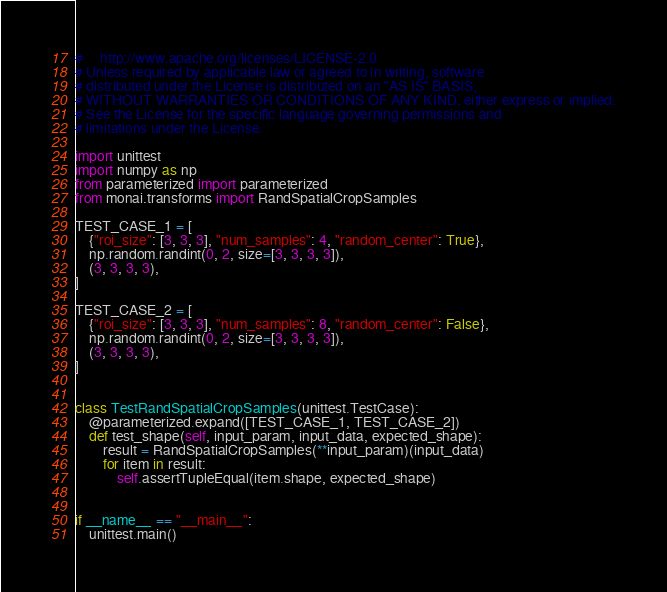<code> <loc_0><loc_0><loc_500><loc_500><_Python_>#     http://www.apache.org/licenses/LICENSE-2.0
# Unless required by applicable law or agreed to in writing, software
# distributed under the License is distributed on an "AS IS" BASIS,
# WITHOUT WARRANTIES OR CONDITIONS OF ANY KIND, either express or implied.
# See the License for the specific language governing permissions and
# limitations under the License.

import unittest
import numpy as np
from parameterized import parameterized
from monai.transforms import RandSpatialCropSamples

TEST_CASE_1 = [
    {"roi_size": [3, 3, 3], "num_samples": 4, "random_center": True},
    np.random.randint(0, 2, size=[3, 3, 3, 3]),
    (3, 3, 3, 3),
]

TEST_CASE_2 = [
    {"roi_size": [3, 3, 3], "num_samples": 8, "random_center": False},
    np.random.randint(0, 2, size=[3, 3, 3, 3]),
    (3, 3, 3, 3),
]


class TestRandSpatialCropSamples(unittest.TestCase):
    @parameterized.expand([TEST_CASE_1, TEST_CASE_2])
    def test_shape(self, input_param, input_data, expected_shape):
        result = RandSpatialCropSamples(**input_param)(input_data)
        for item in result:
            self.assertTupleEqual(item.shape, expected_shape)


if __name__ == "__main__":
    unittest.main()
</code> 